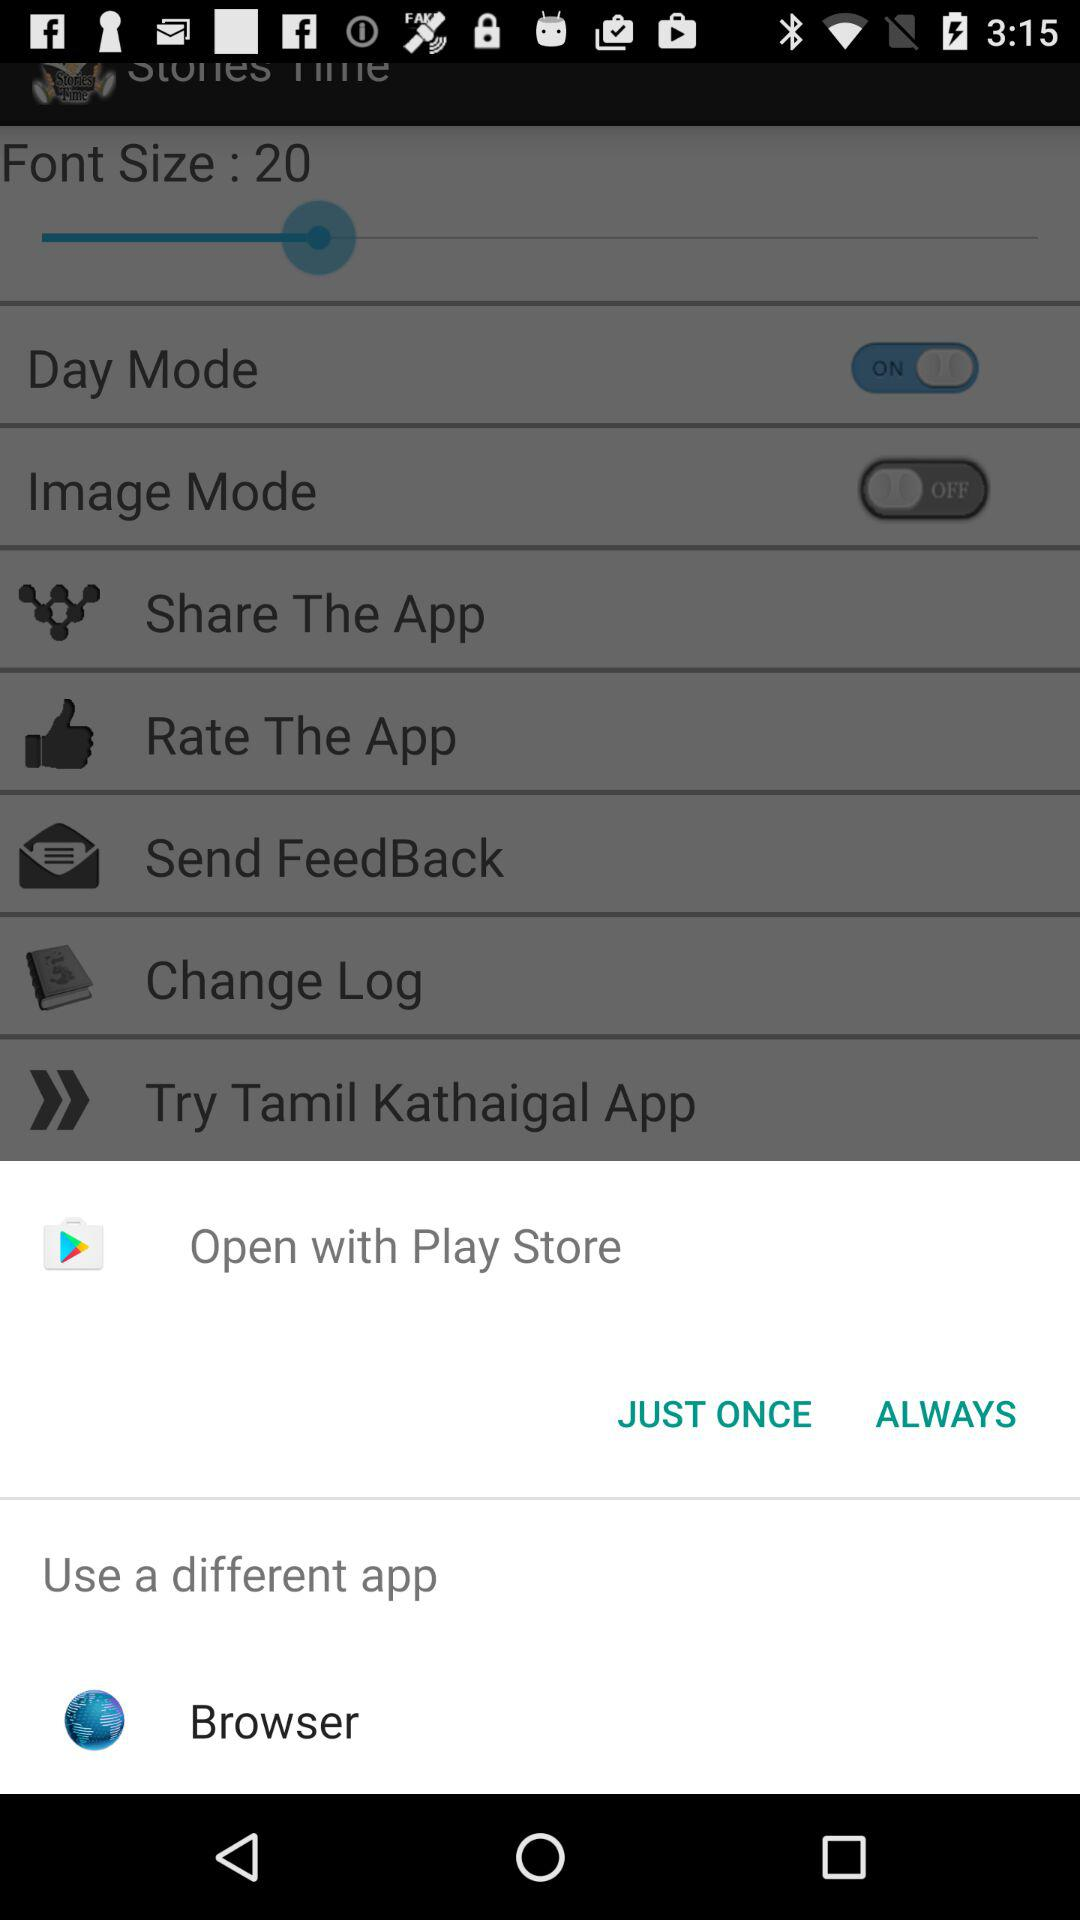What are the options to open with? The option is Play store. 